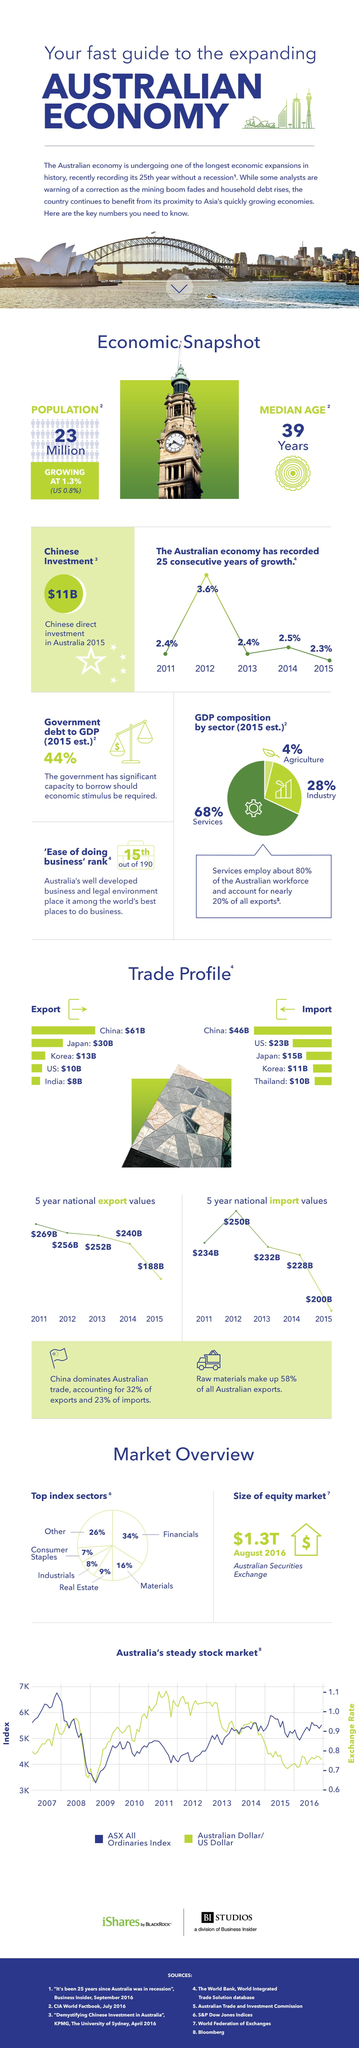Draw attention to some important aspects in this diagram. The growth rate of the Australian economy in the year 2012 was 3.6%. In the year 2014, the national export value in Australia was $240 billion. In 2015, the agricultural sector in Australia accounted for approximately 4% of the country's gross domestic product (GDP). In the year 2013, the national export value in Australia was approximately $252 billion. The national import value in Australia in the year 2015 was approximately $200 billion. 